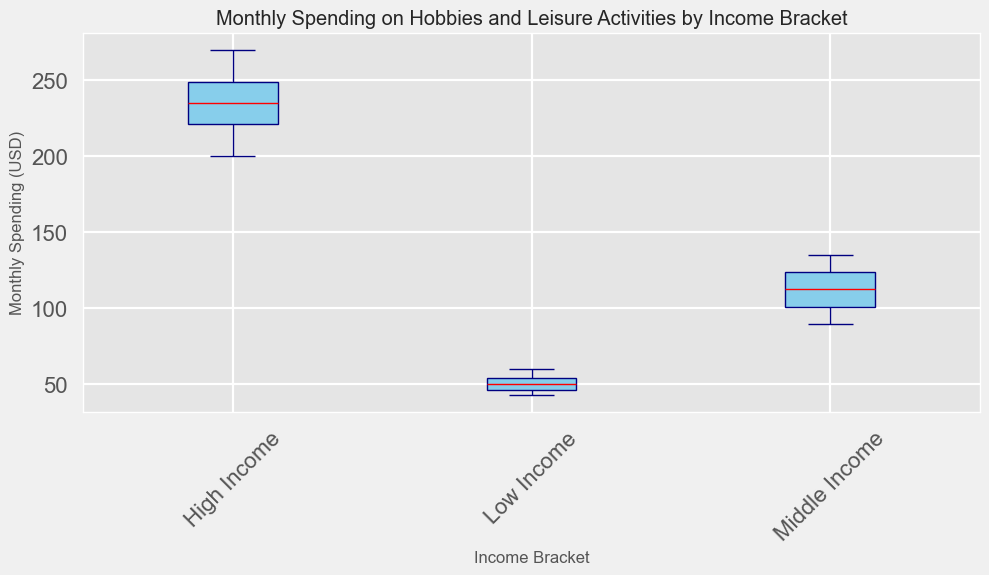What is the median monthly spending for each income bracket? Look at the red lines inside each box to determine the median values. The "Low Income" median is around 50, the "Middle Income" median is around 110, and the "High Income" median is about 240.
Answer: 50 for Low Income, 110 for Middle Income, 240 for High Income Which income bracket has the highest maximum monthly spending? The top whisker of each box represents the maximum value. The "High Income" bracket reaches up to about 270, which is higher than both "Middle Income" (135) and "Low Income" (60).
Answer: High Income Which income bracket has the widest interquartile range (IQR)? The IQR is the length of the box. The "High Income" bracket has the widest IQR because its box (spanning from around 220 to 250) is longer than those of the other brackets.
Answer: High Income Do all income brackets have outliers? Check for small red dots outside the whiskers. All three brackets ("Low Income," "Middle Income," and "High Income") have red dots indicating the presence of outliers.
Answer: Yes What is the approximate range of monthly spending for the "Middle Income" bracket? The range is the difference between the maximum and minimum values, represented by the top and bottom whiskers. For "Middle Income," the range is from about 90 to 135.
Answer: 45 (135 - 90) Which income bracket has the smallest range of monthly spending? The "Low Income" bracket has the smallest range, with values from about 43 to 60.
Answer: Low Income What color represents the boxes in the plot? The main body of each box in the plot is colored blue.
Answer: Blue Is the median monthly spending of "High Income" more than twice the median monthly spending of "Low Income"? The "High Income" median is about 240, while the "Low Income" median is about 50. Since 240 is more than twice 50, the answer is yes.
Answer: Yes How do the outliers in the "High Income" bracket compare to its range? The whiskers of the "High Income" bracket end around 215 and 270, with red dots (outliers) appearing below 215 and above 270, indicating they are notable deviations from the main data range.
Answer: Appear below 215 and above 270 What is the most notable difference in monthly spending between "Low Income" and "High Income" brackets? "Low Income" has both lower median and maximum spending, while "High Income" has significantly higher values in both areas, indicating overall higher spending capacity.
Answer: Median and maximum spending 